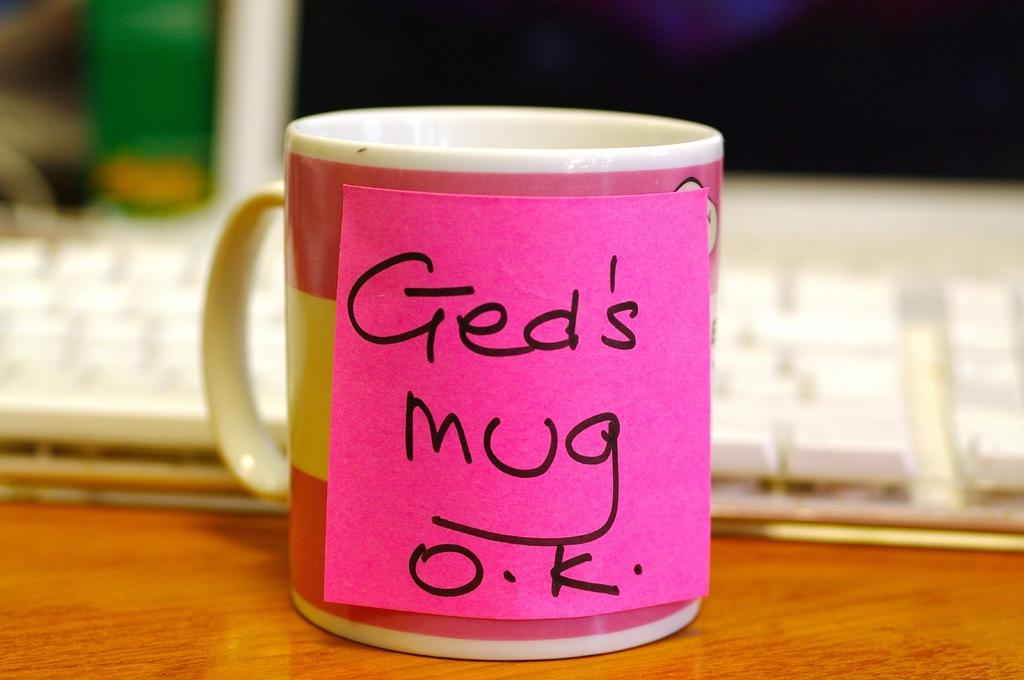Provide a one-sentence caption for the provided image. A coffee mug on an office desk with the words "Ged's mug O.K" written on a sticky note attached to it. 